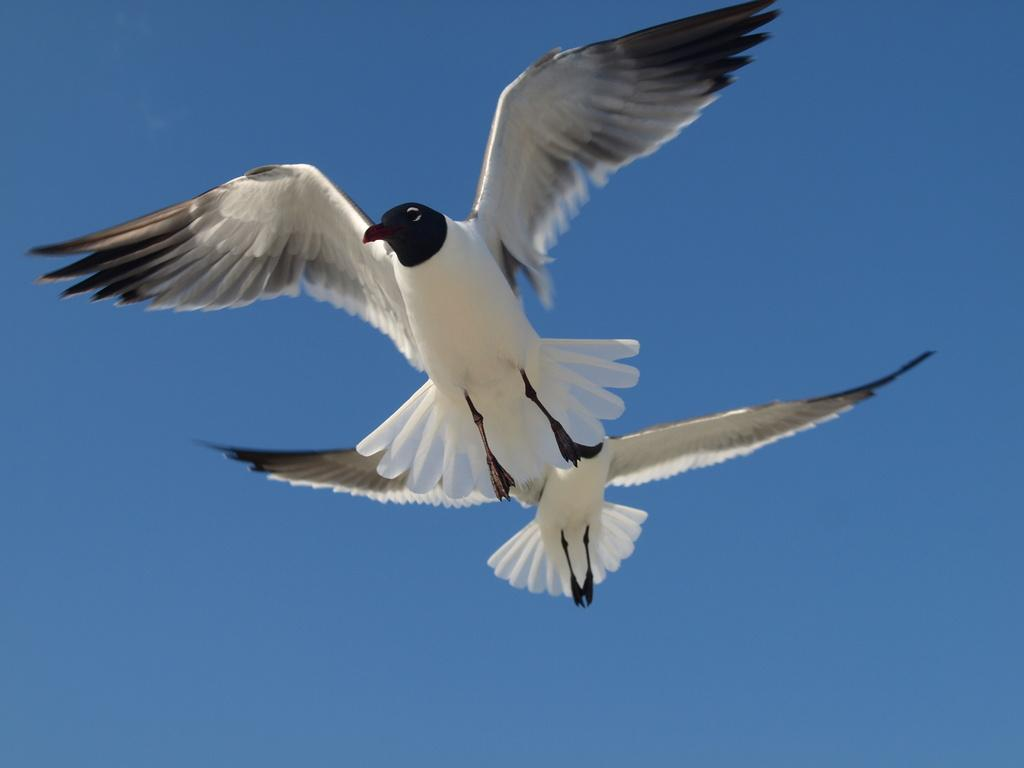What type of animals are present in the image? There are two white color birds in the image. What are the birds doing in the image? The birds are flying in the air. What can be seen in the background of the image? The sky is visible in the background of the image. What is the color of the sky in the image? The color of the sky is blue. Where is the library located in the image? There is no library present in the image; it features two white color birds flying in the air against a blue sky. What design elements can be seen in the image? The image does not depict any specific design elements; it simply shows two birds flying in the air. 